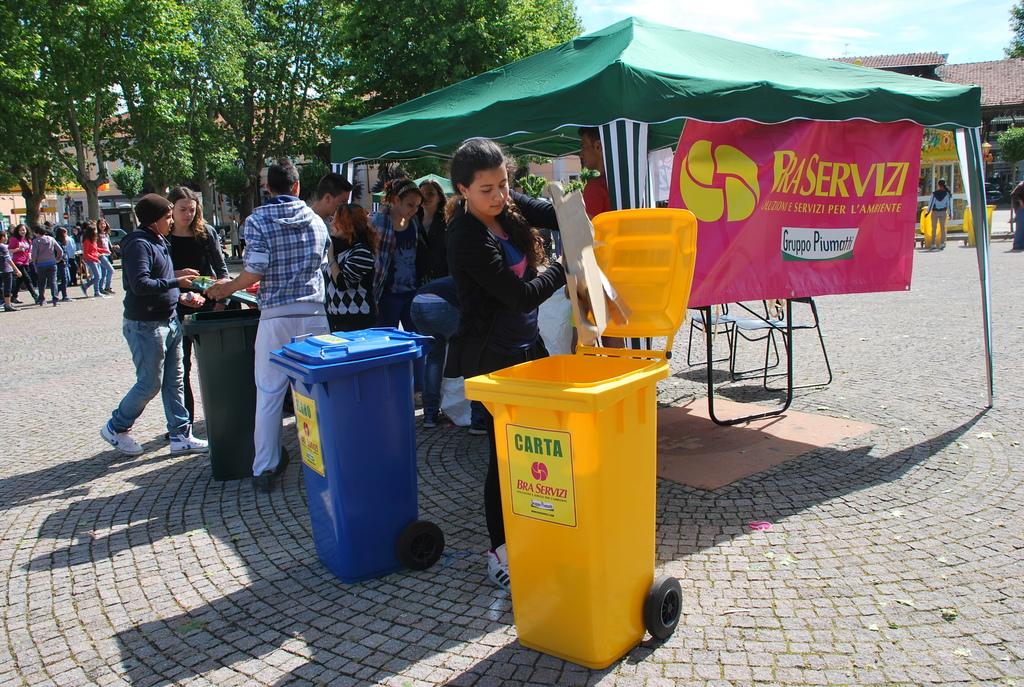What does the sign say?
Offer a terse response. Raservizi. 